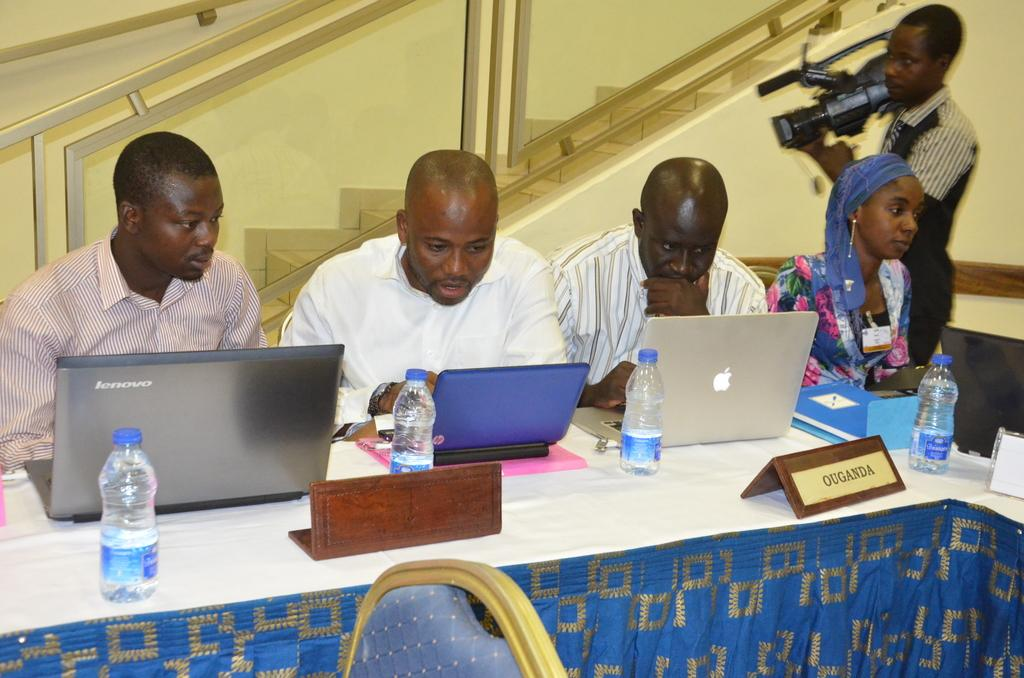<image>
Offer a succinct explanation of the picture presented. 3 men and 1 woman sitting at a table looking at laptops headed by a Mr Ouganda 